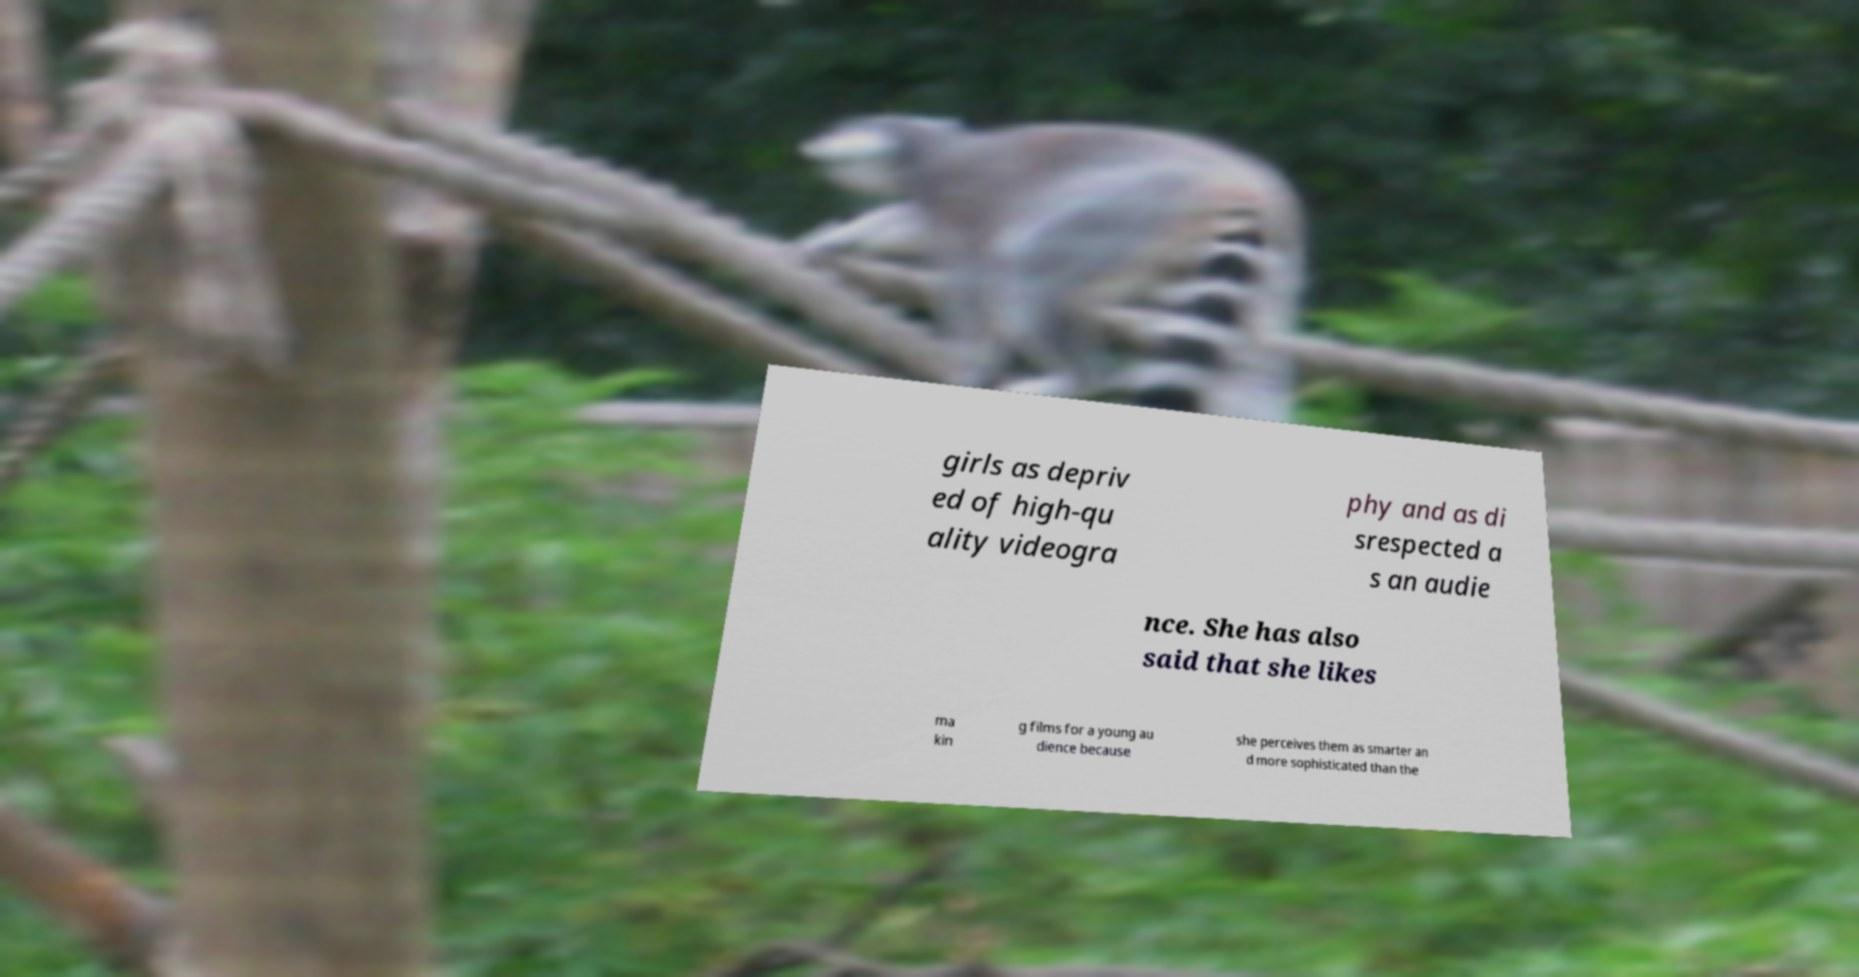Please read and relay the text visible in this image. What does it say? girls as depriv ed of high-qu ality videogra phy and as di srespected a s an audie nce. She has also said that she likes ma kin g films for a young au dience because she perceives them as smarter an d more sophisticated than the 